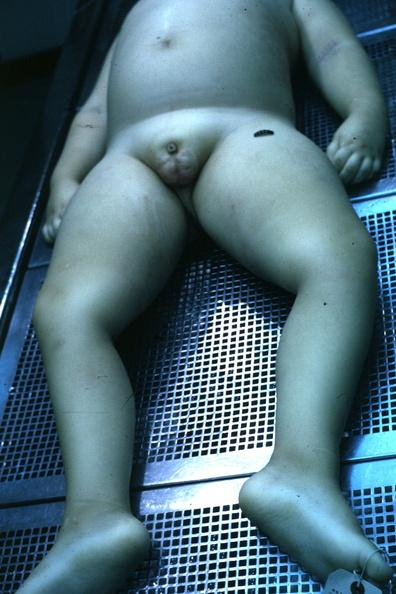what does this image show?
Answer the question using a single word or phrase. View of body with small penis and rather flat scrotal sac case of 7yo with craniopharyngioma 